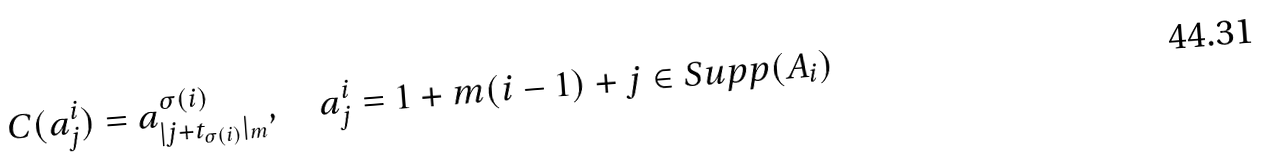<formula> <loc_0><loc_0><loc_500><loc_500>C ( a ^ { i } _ { j } ) = a ^ { \sigma ( i ) } _ { | j + t _ { \sigma ( i ) } | _ { m } } , \quad a ^ { i } _ { j } = 1 + m ( i - 1 ) + j \in S u p p ( A _ { i } )</formula> 